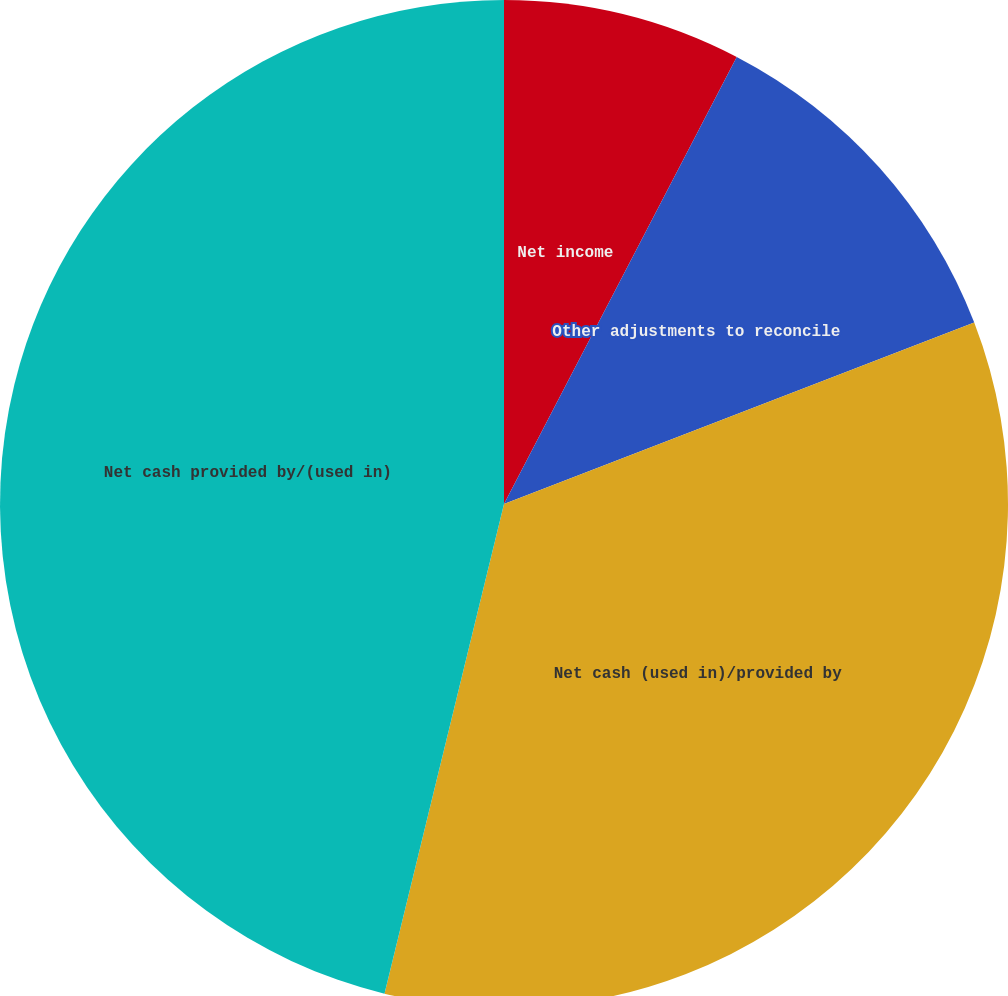Convert chart to OTSL. <chart><loc_0><loc_0><loc_500><loc_500><pie_chart><fcel>Net income<fcel>Other adjustments to reconcile<fcel>Net cash (used in)/provided by<fcel>Net cash provided by/(used in)<nl><fcel>7.64%<fcel>11.5%<fcel>34.67%<fcel>46.19%<nl></chart> 